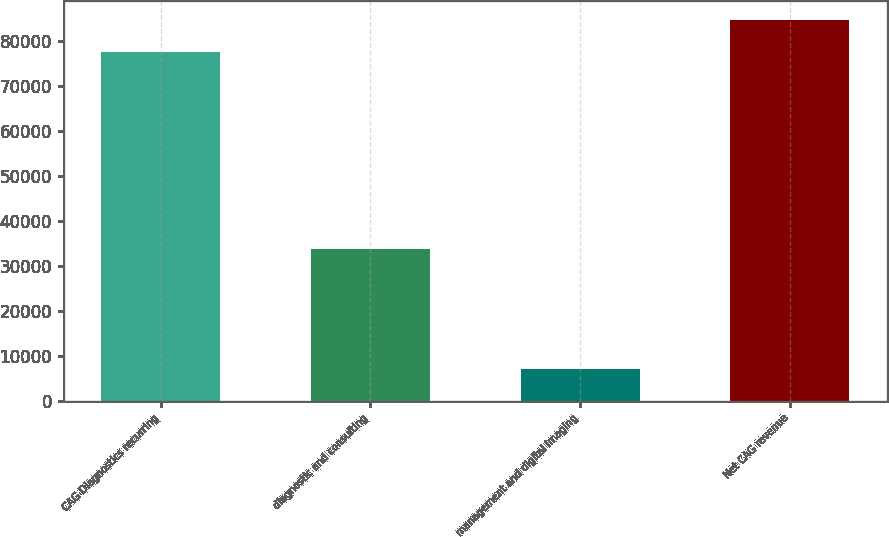Convert chart. <chart><loc_0><loc_0><loc_500><loc_500><bar_chart><fcel>CAG Diagnostics recurring<fcel>diagnostic and consulting<fcel>management and digital imaging<fcel>Net CAG revenue<nl><fcel>77555<fcel>33864<fcel>7206<fcel>84630.2<nl></chart> 